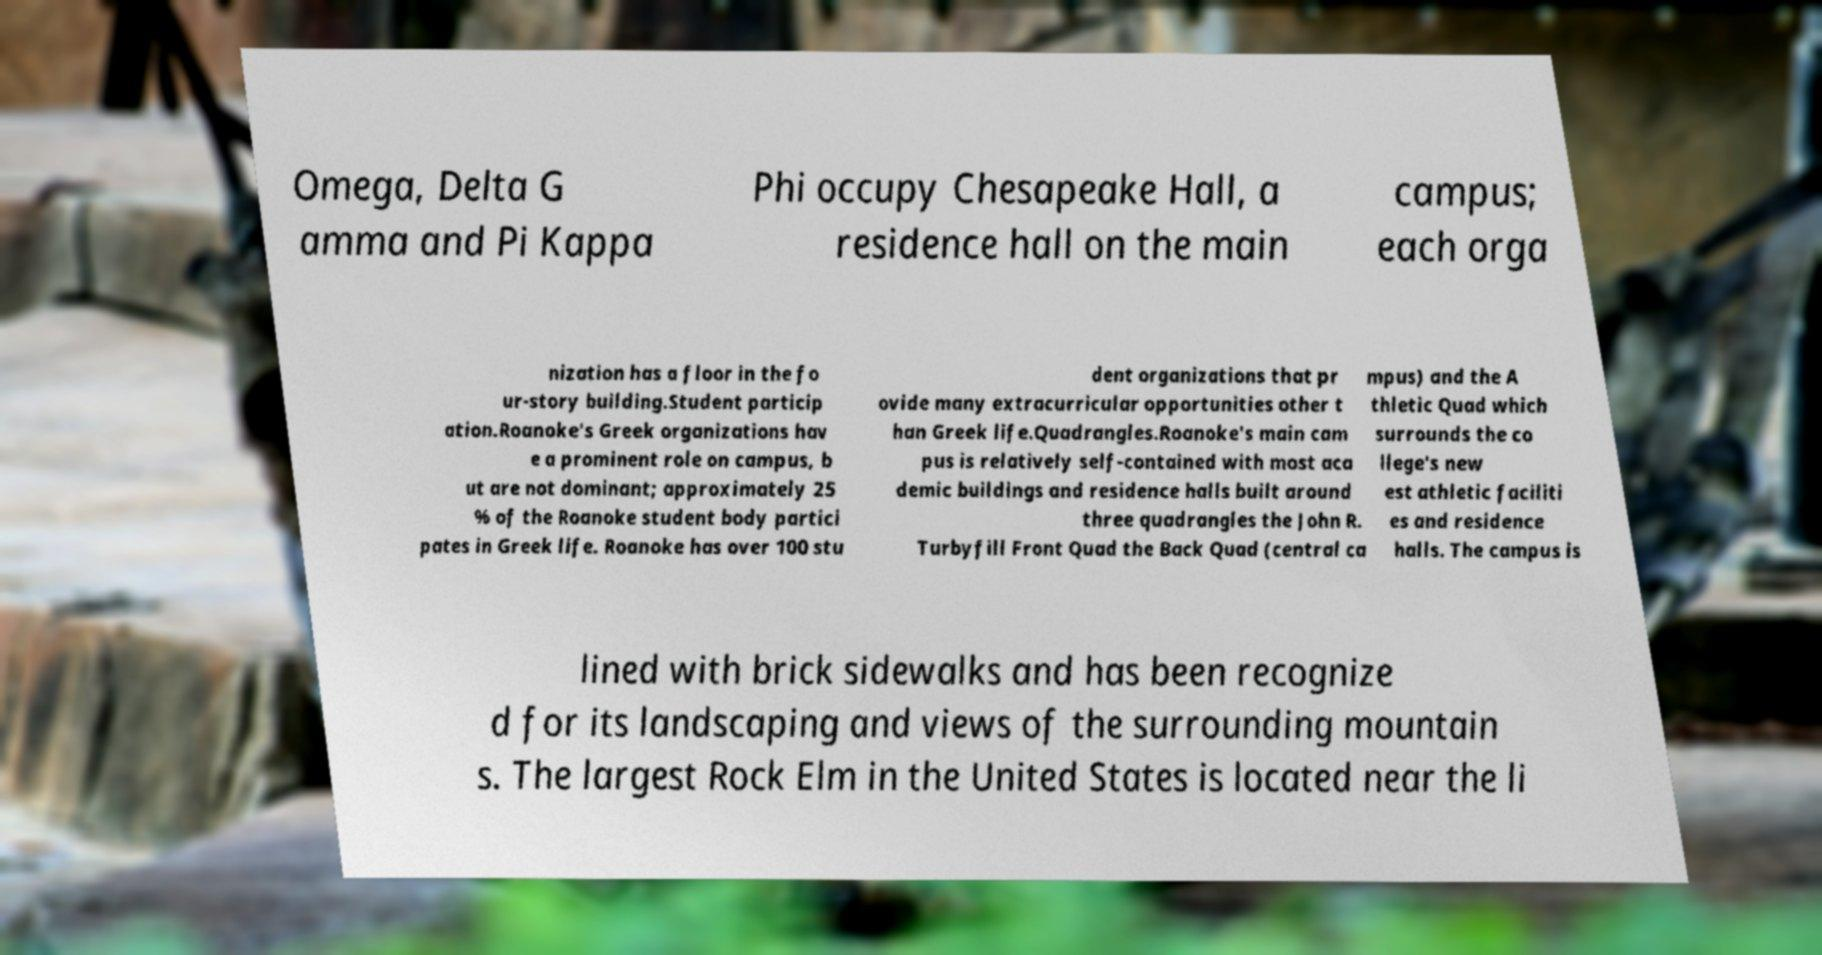Please identify and transcribe the text found in this image. Omega, Delta G amma and Pi Kappa Phi occupy Chesapeake Hall, a residence hall on the main campus; each orga nization has a floor in the fo ur-story building.Student particip ation.Roanoke's Greek organizations hav e a prominent role on campus, b ut are not dominant; approximately 25 % of the Roanoke student body partici pates in Greek life. Roanoke has over 100 stu dent organizations that pr ovide many extracurricular opportunities other t han Greek life.Quadrangles.Roanoke's main cam pus is relatively self-contained with most aca demic buildings and residence halls built around three quadrangles the John R. Turbyfill Front Quad the Back Quad (central ca mpus) and the A thletic Quad which surrounds the co llege's new est athletic faciliti es and residence halls. The campus is lined with brick sidewalks and has been recognize d for its landscaping and views of the surrounding mountain s. The largest Rock Elm in the United States is located near the li 